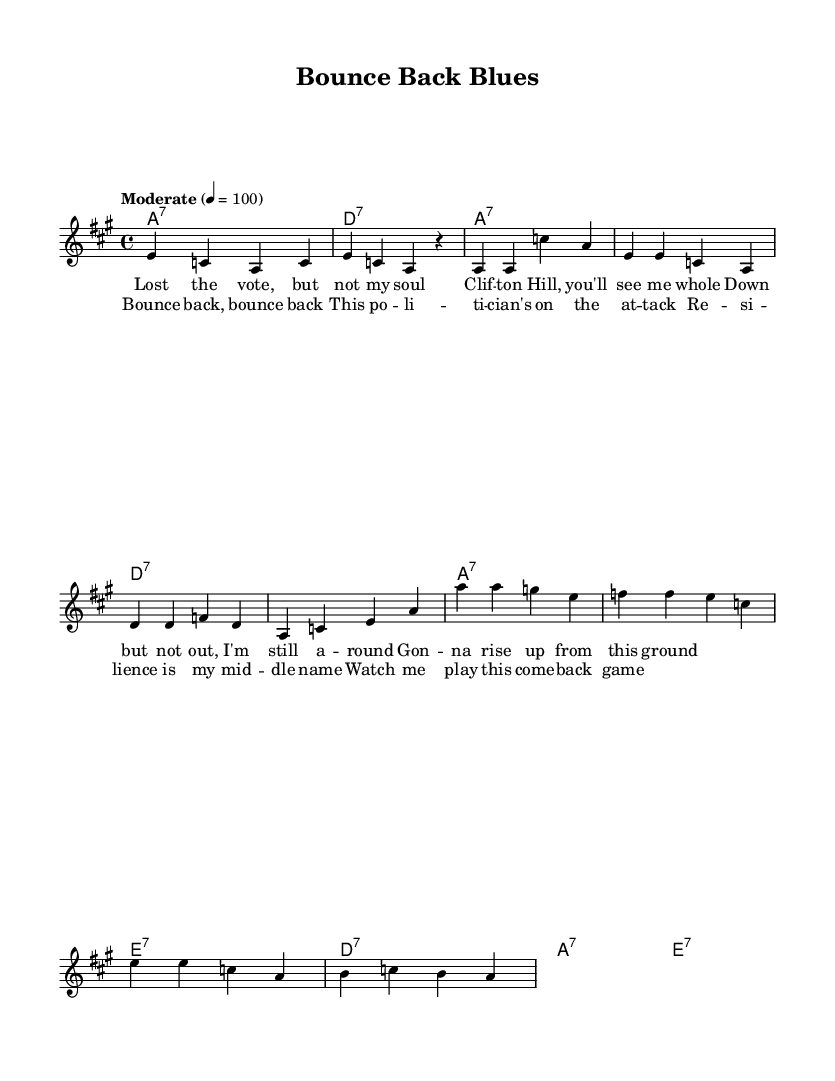What is the key signature of this music? The key signature is A major, indicated by the presence of three sharps (F#, C#, and G#). This can be deduced from the global section of the code where "\key a \major" is specified.
Answer: A major What is the time signature of this music? The time signature is four-four, which is explicitly stated in the global section of the code with "\time 4/4". This indicates that there are four beats per measure.
Answer: Four-four What is the tempo marking of the piece? The tempo marking is "Moderate" with a metronome marking of 100 beats per minute, stated in the global section of the code. This suggests a moderate pace for the performance of the piece.
Answer: Moderate How many measures are in the verse? The verse consists of four measures, each appearing as a group of four quarter notes in the melody. Counting these sections in the provided code results in a total of four measures.
Answer: Four What musical form does this piece primarily represent? The piece primarily represents a verse-chorus form, as evidenced by clearly defined sections labeled as "Verse" and "Chorus" in the code. This structure is typical in Blues music, building upon thematic repetition.
Answer: Verse-chorus What type of harmony is predominantly used in this piece? The harmony is predominantly seventh chords, indicated by the use of "7" in the chord changes. This characteristic is commonly found in Blues music, providing a rich and soulful texture to the sound.
Answer: Seventh chords What is the main theme of the lyrics? The main theme of the lyrics emphasizes resilience and determination, focusing on a political comeback following a loss. This is reflected in phrases like "bounce back" and "gonna rise up from this ground."
Answer: Resilience 